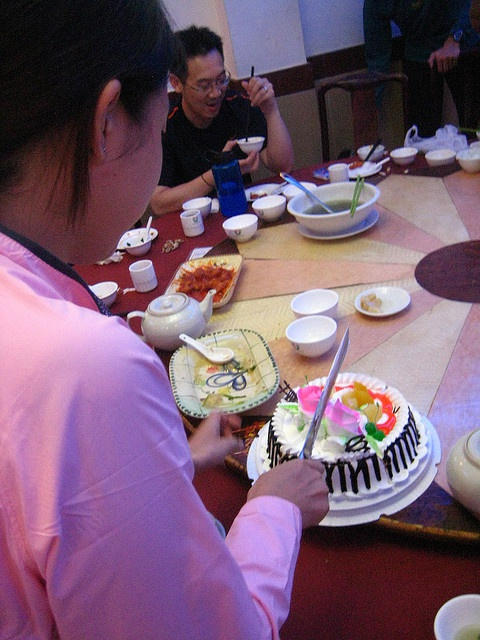Describe the objects in this image and their specific colors. I can see people in darkgray, purple, black, violet, and maroon tones, dining table in black, darkgray, maroon, and lavender tones, cake in black, lavender, and darkgray tones, people in black, maroon, and brown tones, and people in black, purple, navy, and maroon tones in this image. 